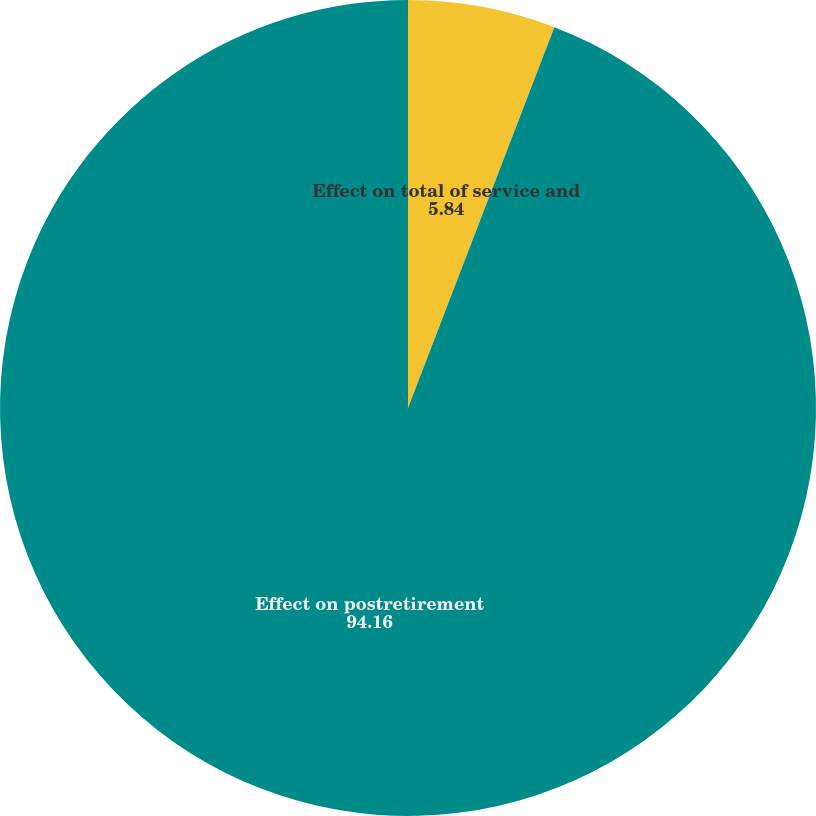Convert chart to OTSL. <chart><loc_0><loc_0><loc_500><loc_500><pie_chart><fcel>Effect on total of service and<fcel>Effect on postretirement<nl><fcel>5.84%<fcel>94.16%<nl></chart> 